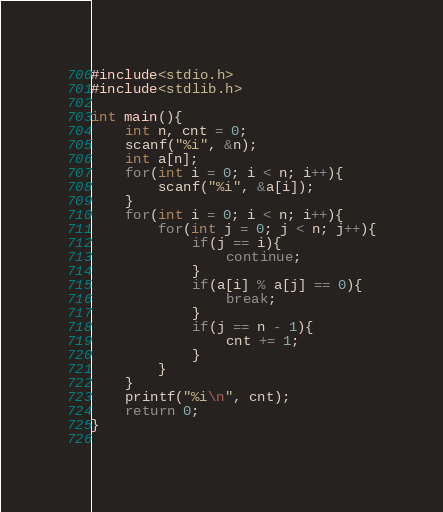Convert code to text. <code><loc_0><loc_0><loc_500><loc_500><_C_>#include<stdio.h>
#include<stdlib.h>

int main(){
	int n, cnt = 0;
	scanf("%i", &n);
	int a[n];
	for(int i = 0; i < n; i++){
		scanf("%i", &a[i]);
	}
	for(int i = 0; i < n; i++){
		for(int j = 0; j < n; j++){
			if(j == i){
				continue;
			}
			if(a[i] % a[j] == 0){
				break;
			}
			if(j == n - 1){
				cnt += 1;
			}
		}
	}
	printf("%i\n", cnt);
	return 0;
}
	
</code> 